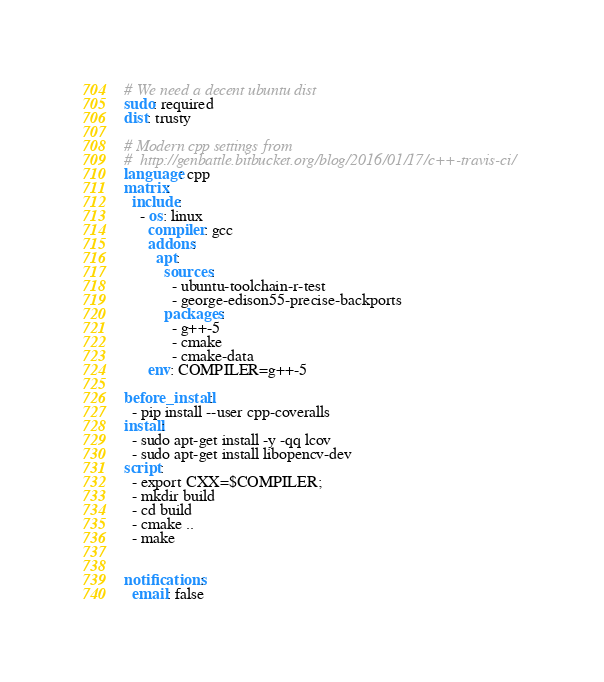Convert code to text. <code><loc_0><loc_0><loc_500><loc_500><_YAML_># We need a decent ubuntu dist
sudo: required
dist: trusty

# Modern cpp settings from
#  http://genbattle.bitbucket.org/blog/2016/01/17/c++-travis-ci/
language: cpp
matrix:
  include:
    - os: linux
      compiler: gcc
      addons:
        apt:
          sources:
            - ubuntu-toolchain-r-test
            - george-edison55-precise-backports
          packages:
            - g++-5
            - cmake
            - cmake-data
      env: COMPILER=g++-5

before_install:
  - pip install --user cpp-coveralls
install:
  - sudo apt-get install -y -qq lcov
  - sudo apt-get install libopencv-dev
script:
  - export CXX=$COMPILER;
  - mkdir build
  - cd build
  - cmake ..
  - make


notifications:
  email: false
</code> 